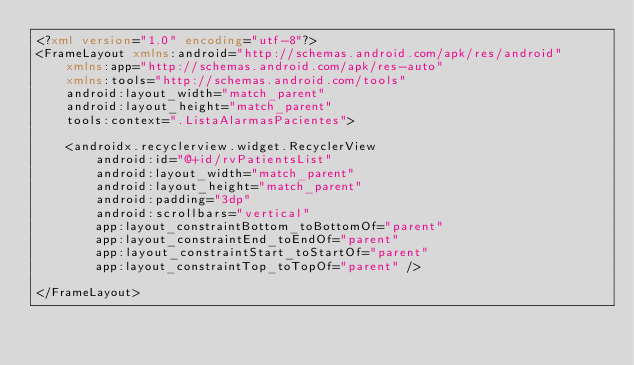<code> <loc_0><loc_0><loc_500><loc_500><_XML_><?xml version="1.0" encoding="utf-8"?>
<FrameLayout xmlns:android="http://schemas.android.com/apk/res/android"
    xmlns:app="http://schemas.android.com/apk/res-auto"
    xmlns:tools="http://schemas.android.com/tools"
    android:layout_width="match_parent"
    android:layout_height="match_parent"
    tools:context=".ListaAlarmasPacientes">

    <androidx.recyclerview.widget.RecyclerView
        android:id="@+id/rvPatientsList"
        android:layout_width="match_parent"
        android:layout_height="match_parent"
        android:padding="3dp"
        android:scrollbars="vertical"
        app:layout_constraintBottom_toBottomOf="parent"
        app:layout_constraintEnd_toEndOf="parent"
        app:layout_constraintStart_toStartOf="parent"
        app:layout_constraintTop_toTopOf="parent" />

</FrameLayout></code> 